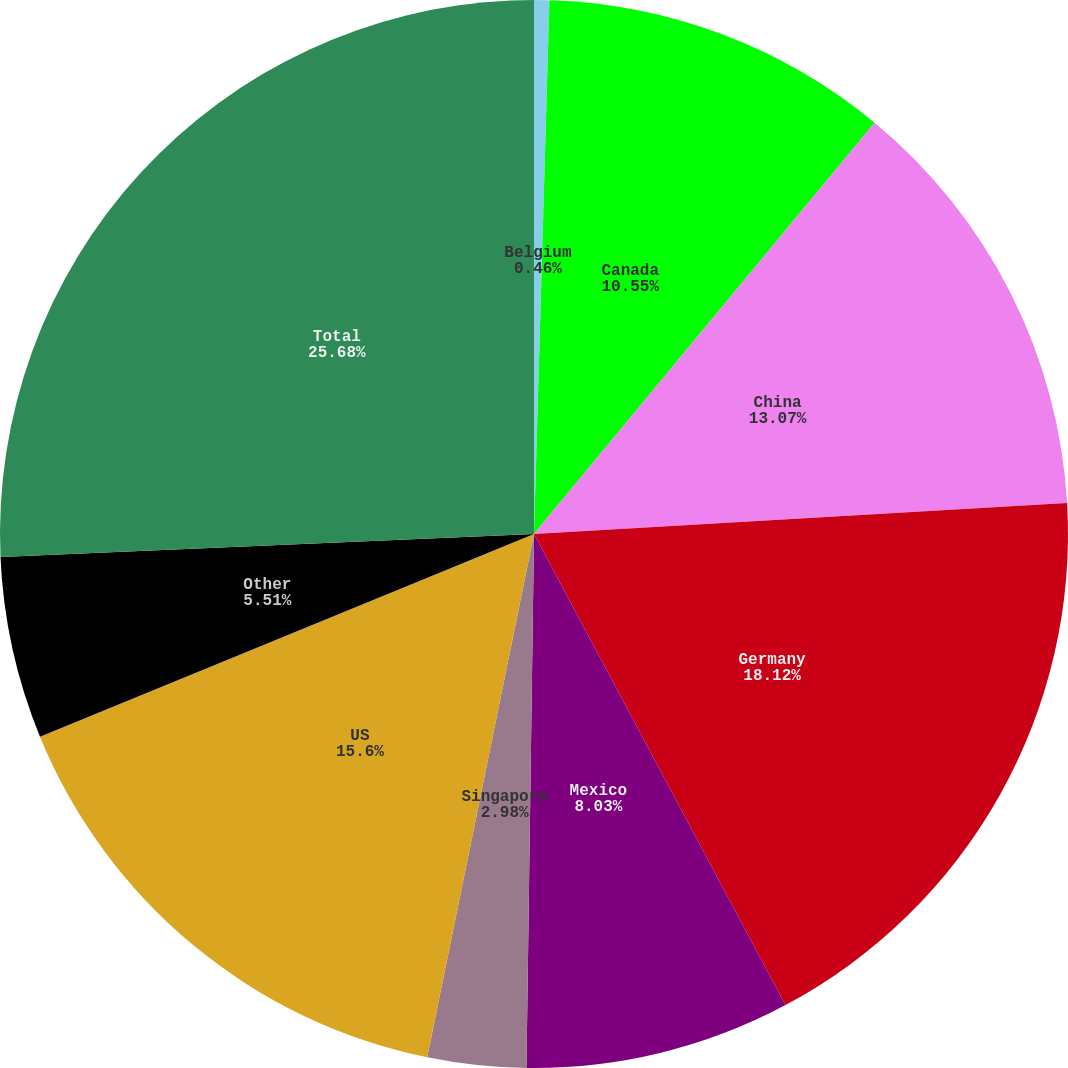Convert chart. <chart><loc_0><loc_0><loc_500><loc_500><pie_chart><fcel>Belgium<fcel>Canada<fcel>China<fcel>Germany<fcel>Mexico<fcel>Singapore<fcel>US<fcel>Other<fcel>Total<nl><fcel>0.46%<fcel>10.55%<fcel>13.07%<fcel>18.12%<fcel>8.03%<fcel>2.98%<fcel>15.6%<fcel>5.51%<fcel>25.69%<nl></chart> 